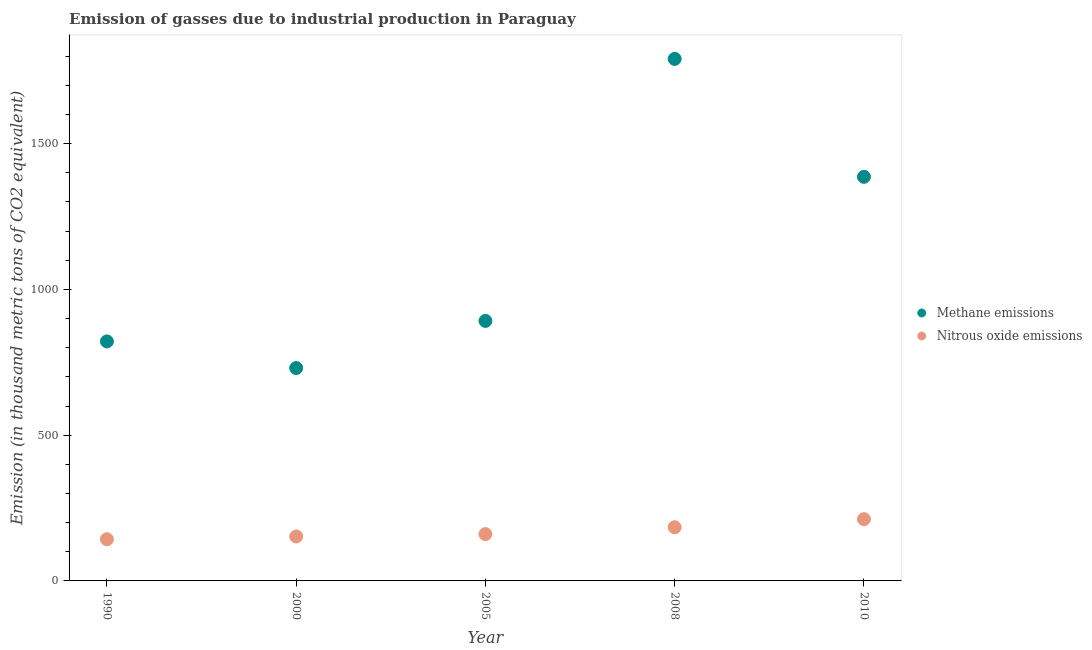Is the number of dotlines equal to the number of legend labels?
Give a very brief answer. Yes. What is the amount of nitrous oxide emissions in 2000?
Give a very brief answer. 152.5. Across all years, what is the maximum amount of methane emissions?
Ensure brevity in your answer.  1790.7. Across all years, what is the minimum amount of nitrous oxide emissions?
Provide a succinct answer. 143. In which year was the amount of methane emissions minimum?
Offer a very short reply. 2000. What is the total amount of methane emissions in the graph?
Offer a very short reply. 5620.6. What is the difference between the amount of nitrous oxide emissions in 2000 and that in 2008?
Your answer should be very brief. -31.6. What is the difference between the amount of nitrous oxide emissions in 2000 and the amount of methane emissions in 2008?
Provide a succinct answer. -1638.2. What is the average amount of methane emissions per year?
Offer a terse response. 1124.12. In the year 2010, what is the difference between the amount of methane emissions and amount of nitrous oxide emissions?
Make the answer very short. 1174.3. What is the ratio of the amount of methane emissions in 1990 to that in 2000?
Keep it short and to the point. 1.13. Is the amount of methane emissions in 2005 less than that in 2010?
Offer a very short reply. Yes. Is the difference between the amount of methane emissions in 2008 and 2010 greater than the difference between the amount of nitrous oxide emissions in 2008 and 2010?
Provide a short and direct response. Yes. What is the difference between the highest and the second highest amount of nitrous oxide emissions?
Keep it short and to the point. 27.8. What is the difference between the highest and the lowest amount of nitrous oxide emissions?
Your answer should be compact. 68.9. In how many years, is the amount of methane emissions greater than the average amount of methane emissions taken over all years?
Offer a terse response. 2. Is the amount of nitrous oxide emissions strictly greater than the amount of methane emissions over the years?
Give a very brief answer. No. How many dotlines are there?
Make the answer very short. 2. What is the difference between two consecutive major ticks on the Y-axis?
Provide a short and direct response. 500. Are the values on the major ticks of Y-axis written in scientific E-notation?
Provide a short and direct response. No. Does the graph contain any zero values?
Provide a succinct answer. No. Does the graph contain grids?
Give a very brief answer. No. How many legend labels are there?
Offer a very short reply. 2. What is the title of the graph?
Keep it short and to the point. Emission of gasses due to industrial production in Paraguay. Does "Subsidies" appear as one of the legend labels in the graph?
Offer a terse response. No. What is the label or title of the X-axis?
Keep it short and to the point. Year. What is the label or title of the Y-axis?
Make the answer very short. Emission (in thousand metric tons of CO2 equivalent). What is the Emission (in thousand metric tons of CO2 equivalent) in Methane emissions in 1990?
Offer a very short reply. 821.6. What is the Emission (in thousand metric tons of CO2 equivalent) of Nitrous oxide emissions in 1990?
Offer a terse response. 143. What is the Emission (in thousand metric tons of CO2 equivalent) in Methane emissions in 2000?
Keep it short and to the point. 730.2. What is the Emission (in thousand metric tons of CO2 equivalent) of Nitrous oxide emissions in 2000?
Your answer should be compact. 152.5. What is the Emission (in thousand metric tons of CO2 equivalent) in Methane emissions in 2005?
Your answer should be compact. 891.9. What is the Emission (in thousand metric tons of CO2 equivalent) of Nitrous oxide emissions in 2005?
Offer a very short reply. 160.6. What is the Emission (in thousand metric tons of CO2 equivalent) of Methane emissions in 2008?
Your response must be concise. 1790.7. What is the Emission (in thousand metric tons of CO2 equivalent) of Nitrous oxide emissions in 2008?
Give a very brief answer. 184.1. What is the Emission (in thousand metric tons of CO2 equivalent) of Methane emissions in 2010?
Your answer should be compact. 1386.2. What is the Emission (in thousand metric tons of CO2 equivalent) of Nitrous oxide emissions in 2010?
Keep it short and to the point. 211.9. Across all years, what is the maximum Emission (in thousand metric tons of CO2 equivalent) in Methane emissions?
Your answer should be compact. 1790.7. Across all years, what is the maximum Emission (in thousand metric tons of CO2 equivalent) of Nitrous oxide emissions?
Provide a succinct answer. 211.9. Across all years, what is the minimum Emission (in thousand metric tons of CO2 equivalent) in Methane emissions?
Provide a succinct answer. 730.2. Across all years, what is the minimum Emission (in thousand metric tons of CO2 equivalent) of Nitrous oxide emissions?
Provide a succinct answer. 143. What is the total Emission (in thousand metric tons of CO2 equivalent) in Methane emissions in the graph?
Provide a succinct answer. 5620.6. What is the total Emission (in thousand metric tons of CO2 equivalent) of Nitrous oxide emissions in the graph?
Provide a succinct answer. 852.1. What is the difference between the Emission (in thousand metric tons of CO2 equivalent) in Methane emissions in 1990 and that in 2000?
Provide a short and direct response. 91.4. What is the difference between the Emission (in thousand metric tons of CO2 equivalent) in Methane emissions in 1990 and that in 2005?
Offer a very short reply. -70.3. What is the difference between the Emission (in thousand metric tons of CO2 equivalent) of Nitrous oxide emissions in 1990 and that in 2005?
Your answer should be very brief. -17.6. What is the difference between the Emission (in thousand metric tons of CO2 equivalent) of Methane emissions in 1990 and that in 2008?
Make the answer very short. -969.1. What is the difference between the Emission (in thousand metric tons of CO2 equivalent) of Nitrous oxide emissions in 1990 and that in 2008?
Provide a succinct answer. -41.1. What is the difference between the Emission (in thousand metric tons of CO2 equivalent) in Methane emissions in 1990 and that in 2010?
Your response must be concise. -564.6. What is the difference between the Emission (in thousand metric tons of CO2 equivalent) of Nitrous oxide emissions in 1990 and that in 2010?
Your response must be concise. -68.9. What is the difference between the Emission (in thousand metric tons of CO2 equivalent) in Methane emissions in 2000 and that in 2005?
Your answer should be compact. -161.7. What is the difference between the Emission (in thousand metric tons of CO2 equivalent) of Nitrous oxide emissions in 2000 and that in 2005?
Give a very brief answer. -8.1. What is the difference between the Emission (in thousand metric tons of CO2 equivalent) of Methane emissions in 2000 and that in 2008?
Your answer should be very brief. -1060.5. What is the difference between the Emission (in thousand metric tons of CO2 equivalent) of Nitrous oxide emissions in 2000 and that in 2008?
Give a very brief answer. -31.6. What is the difference between the Emission (in thousand metric tons of CO2 equivalent) in Methane emissions in 2000 and that in 2010?
Provide a succinct answer. -656. What is the difference between the Emission (in thousand metric tons of CO2 equivalent) of Nitrous oxide emissions in 2000 and that in 2010?
Provide a succinct answer. -59.4. What is the difference between the Emission (in thousand metric tons of CO2 equivalent) in Methane emissions in 2005 and that in 2008?
Provide a succinct answer. -898.8. What is the difference between the Emission (in thousand metric tons of CO2 equivalent) in Nitrous oxide emissions in 2005 and that in 2008?
Your answer should be compact. -23.5. What is the difference between the Emission (in thousand metric tons of CO2 equivalent) in Methane emissions in 2005 and that in 2010?
Your answer should be compact. -494.3. What is the difference between the Emission (in thousand metric tons of CO2 equivalent) of Nitrous oxide emissions in 2005 and that in 2010?
Make the answer very short. -51.3. What is the difference between the Emission (in thousand metric tons of CO2 equivalent) in Methane emissions in 2008 and that in 2010?
Your answer should be compact. 404.5. What is the difference between the Emission (in thousand metric tons of CO2 equivalent) in Nitrous oxide emissions in 2008 and that in 2010?
Keep it short and to the point. -27.8. What is the difference between the Emission (in thousand metric tons of CO2 equivalent) of Methane emissions in 1990 and the Emission (in thousand metric tons of CO2 equivalent) of Nitrous oxide emissions in 2000?
Make the answer very short. 669.1. What is the difference between the Emission (in thousand metric tons of CO2 equivalent) of Methane emissions in 1990 and the Emission (in thousand metric tons of CO2 equivalent) of Nitrous oxide emissions in 2005?
Offer a terse response. 661. What is the difference between the Emission (in thousand metric tons of CO2 equivalent) in Methane emissions in 1990 and the Emission (in thousand metric tons of CO2 equivalent) in Nitrous oxide emissions in 2008?
Your response must be concise. 637.5. What is the difference between the Emission (in thousand metric tons of CO2 equivalent) in Methane emissions in 1990 and the Emission (in thousand metric tons of CO2 equivalent) in Nitrous oxide emissions in 2010?
Keep it short and to the point. 609.7. What is the difference between the Emission (in thousand metric tons of CO2 equivalent) of Methane emissions in 2000 and the Emission (in thousand metric tons of CO2 equivalent) of Nitrous oxide emissions in 2005?
Make the answer very short. 569.6. What is the difference between the Emission (in thousand metric tons of CO2 equivalent) of Methane emissions in 2000 and the Emission (in thousand metric tons of CO2 equivalent) of Nitrous oxide emissions in 2008?
Offer a very short reply. 546.1. What is the difference between the Emission (in thousand metric tons of CO2 equivalent) of Methane emissions in 2000 and the Emission (in thousand metric tons of CO2 equivalent) of Nitrous oxide emissions in 2010?
Your answer should be compact. 518.3. What is the difference between the Emission (in thousand metric tons of CO2 equivalent) in Methane emissions in 2005 and the Emission (in thousand metric tons of CO2 equivalent) in Nitrous oxide emissions in 2008?
Make the answer very short. 707.8. What is the difference between the Emission (in thousand metric tons of CO2 equivalent) of Methane emissions in 2005 and the Emission (in thousand metric tons of CO2 equivalent) of Nitrous oxide emissions in 2010?
Give a very brief answer. 680. What is the difference between the Emission (in thousand metric tons of CO2 equivalent) in Methane emissions in 2008 and the Emission (in thousand metric tons of CO2 equivalent) in Nitrous oxide emissions in 2010?
Provide a succinct answer. 1578.8. What is the average Emission (in thousand metric tons of CO2 equivalent) of Methane emissions per year?
Keep it short and to the point. 1124.12. What is the average Emission (in thousand metric tons of CO2 equivalent) of Nitrous oxide emissions per year?
Ensure brevity in your answer.  170.42. In the year 1990, what is the difference between the Emission (in thousand metric tons of CO2 equivalent) of Methane emissions and Emission (in thousand metric tons of CO2 equivalent) of Nitrous oxide emissions?
Your answer should be compact. 678.6. In the year 2000, what is the difference between the Emission (in thousand metric tons of CO2 equivalent) in Methane emissions and Emission (in thousand metric tons of CO2 equivalent) in Nitrous oxide emissions?
Provide a short and direct response. 577.7. In the year 2005, what is the difference between the Emission (in thousand metric tons of CO2 equivalent) in Methane emissions and Emission (in thousand metric tons of CO2 equivalent) in Nitrous oxide emissions?
Provide a succinct answer. 731.3. In the year 2008, what is the difference between the Emission (in thousand metric tons of CO2 equivalent) in Methane emissions and Emission (in thousand metric tons of CO2 equivalent) in Nitrous oxide emissions?
Provide a short and direct response. 1606.6. In the year 2010, what is the difference between the Emission (in thousand metric tons of CO2 equivalent) of Methane emissions and Emission (in thousand metric tons of CO2 equivalent) of Nitrous oxide emissions?
Ensure brevity in your answer.  1174.3. What is the ratio of the Emission (in thousand metric tons of CO2 equivalent) in Methane emissions in 1990 to that in 2000?
Your answer should be very brief. 1.13. What is the ratio of the Emission (in thousand metric tons of CO2 equivalent) in Nitrous oxide emissions in 1990 to that in 2000?
Provide a short and direct response. 0.94. What is the ratio of the Emission (in thousand metric tons of CO2 equivalent) in Methane emissions in 1990 to that in 2005?
Offer a terse response. 0.92. What is the ratio of the Emission (in thousand metric tons of CO2 equivalent) of Nitrous oxide emissions in 1990 to that in 2005?
Keep it short and to the point. 0.89. What is the ratio of the Emission (in thousand metric tons of CO2 equivalent) of Methane emissions in 1990 to that in 2008?
Your answer should be very brief. 0.46. What is the ratio of the Emission (in thousand metric tons of CO2 equivalent) of Nitrous oxide emissions in 1990 to that in 2008?
Provide a short and direct response. 0.78. What is the ratio of the Emission (in thousand metric tons of CO2 equivalent) of Methane emissions in 1990 to that in 2010?
Ensure brevity in your answer.  0.59. What is the ratio of the Emission (in thousand metric tons of CO2 equivalent) of Nitrous oxide emissions in 1990 to that in 2010?
Keep it short and to the point. 0.67. What is the ratio of the Emission (in thousand metric tons of CO2 equivalent) of Methane emissions in 2000 to that in 2005?
Your answer should be very brief. 0.82. What is the ratio of the Emission (in thousand metric tons of CO2 equivalent) in Nitrous oxide emissions in 2000 to that in 2005?
Provide a succinct answer. 0.95. What is the ratio of the Emission (in thousand metric tons of CO2 equivalent) of Methane emissions in 2000 to that in 2008?
Make the answer very short. 0.41. What is the ratio of the Emission (in thousand metric tons of CO2 equivalent) of Nitrous oxide emissions in 2000 to that in 2008?
Ensure brevity in your answer.  0.83. What is the ratio of the Emission (in thousand metric tons of CO2 equivalent) in Methane emissions in 2000 to that in 2010?
Give a very brief answer. 0.53. What is the ratio of the Emission (in thousand metric tons of CO2 equivalent) in Nitrous oxide emissions in 2000 to that in 2010?
Provide a short and direct response. 0.72. What is the ratio of the Emission (in thousand metric tons of CO2 equivalent) in Methane emissions in 2005 to that in 2008?
Offer a terse response. 0.5. What is the ratio of the Emission (in thousand metric tons of CO2 equivalent) in Nitrous oxide emissions in 2005 to that in 2008?
Make the answer very short. 0.87. What is the ratio of the Emission (in thousand metric tons of CO2 equivalent) in Methane emissions in 2005 to that in 2010?
Give a very brief answer. 0.64. What is the ratio of the Emission (in thousand metric tons of CO2 equivalent) in Nitrous oxide emissions in 2005 to that in 2010?
Your response must be concise. 0.76. What is the ratio of the Emission (in thousand metric tons of CO2 equivalent) in Methane emissions in 2008 to that in 2010?
Provide a succinct answer. 1.29. What is the ratio of the Emission (in thousand metric tons of CO2 equivalent) of Nitrous oxide emissions in 2008 to that in 2010?
Give a very brief answer. 0.87. What is the difference between the highest and the second highest Emission (in thousand metric tons of CO2 equivalent) of Methane emissions?
Your answer should be very brief. 404.5. What is the difference between the highest and the second highest Emission (in thousand metric tons of CO2 equivalent) in Nitrous oxide emissions?
Your answer should be compact. 27.8. What is the difference between the highest and the lowest Emission (in thousand metric tons of CO2 equivalent) in Methane emissions?
Your answer should be very brief. 1060.5. What is the difference between the highest and the lowest Emission (in thousand metric tons of CO2 equivalent) of Nitrous oxide emissions?
Your answer should be very brief. 68.9. 